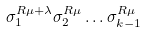Convert formula to latex. <formula><loc_0><loc_0><loc_500><loc_500>\sigma _ { 1 } ^ { R \mu + \lambda } \sigma _ { 2 } ^ { R \mu } \dots \sigma _ { k - 1 } ^ { R \mu }</formula> 